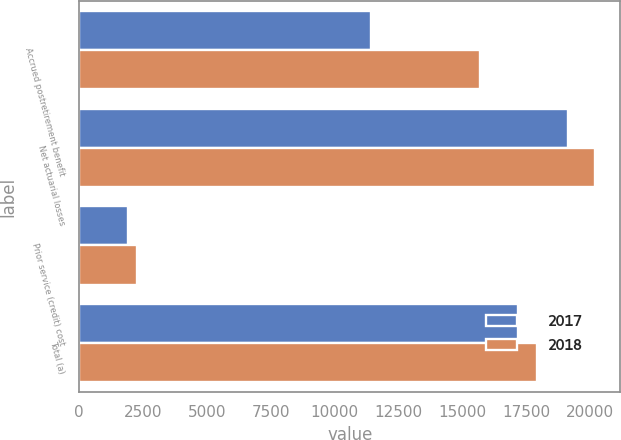Convert chart to OTSL. <chart><loc_0><loc_0><loc_500><loc_500><stacked_bar_chart><ecel><fcel>Accrued postretirement benefit<fcel>Net actuarial losses<fcel>Prior service (credit) cost<fcel>Total (a)<nl><fcel>2017<fcel>11410<fcel>19117<fcel>1931<fcel>17186<nl><fcel>2018<fcel>15703<fcel>20169<fcel>2263<fcel>17906<nl></chart> 